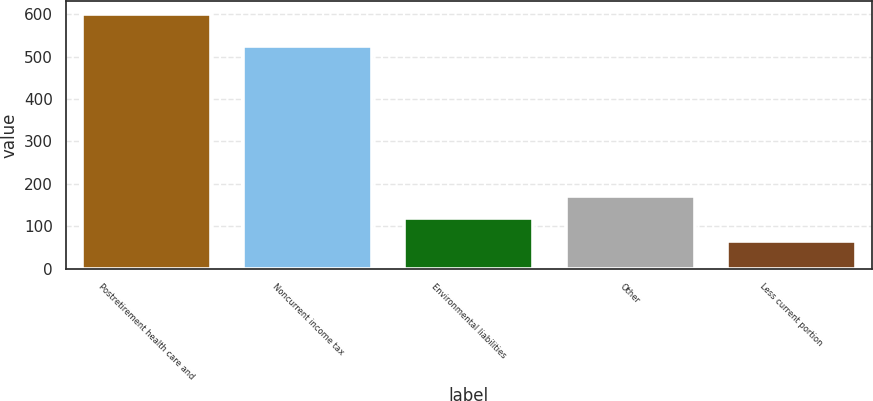Convert chart to OTSL. <chart><loc_0><loc_0><loc_500><loc_500><bar_chart><fcel>Postretirement health care and<fcel>Noncurrent income tax<fcel>Environmental liabilities<fcel>Other<fcel>Less current portion<nl><fcel>600.4<fcel>525.9<fcel>118.27<fcel>171.84<fcel>64.7<nl></chart> 